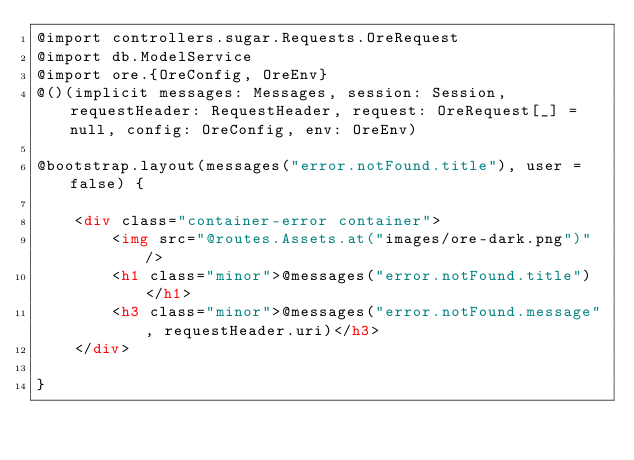Convert code to text. <code><loc_0><loc_0><loc_500><loc_500><_HTML_>@import controllers.sugar.Requests.OreRequest
@import db.ModelService
@import ore.{OreConfig, OreEnv}
@()(implicit messages: Messages, session: Session, requestHeader: RequestHeader, request: OreRequest[_] = null, config: OreConfig, env: OreEnv)

@bootstrap.layout(messages("error.notFound.title"), user = false) {

    <div class="container-error container">
        <img src="@routes.Assets.at("images/ore-dark.png")" />
        <h1 class="minor">@messages("error.notFound.title")</h1>
        <h3 class="minor">@messages("error.notFound.message", requestHeader.uri)</h3>
    </div>

}
</code> 